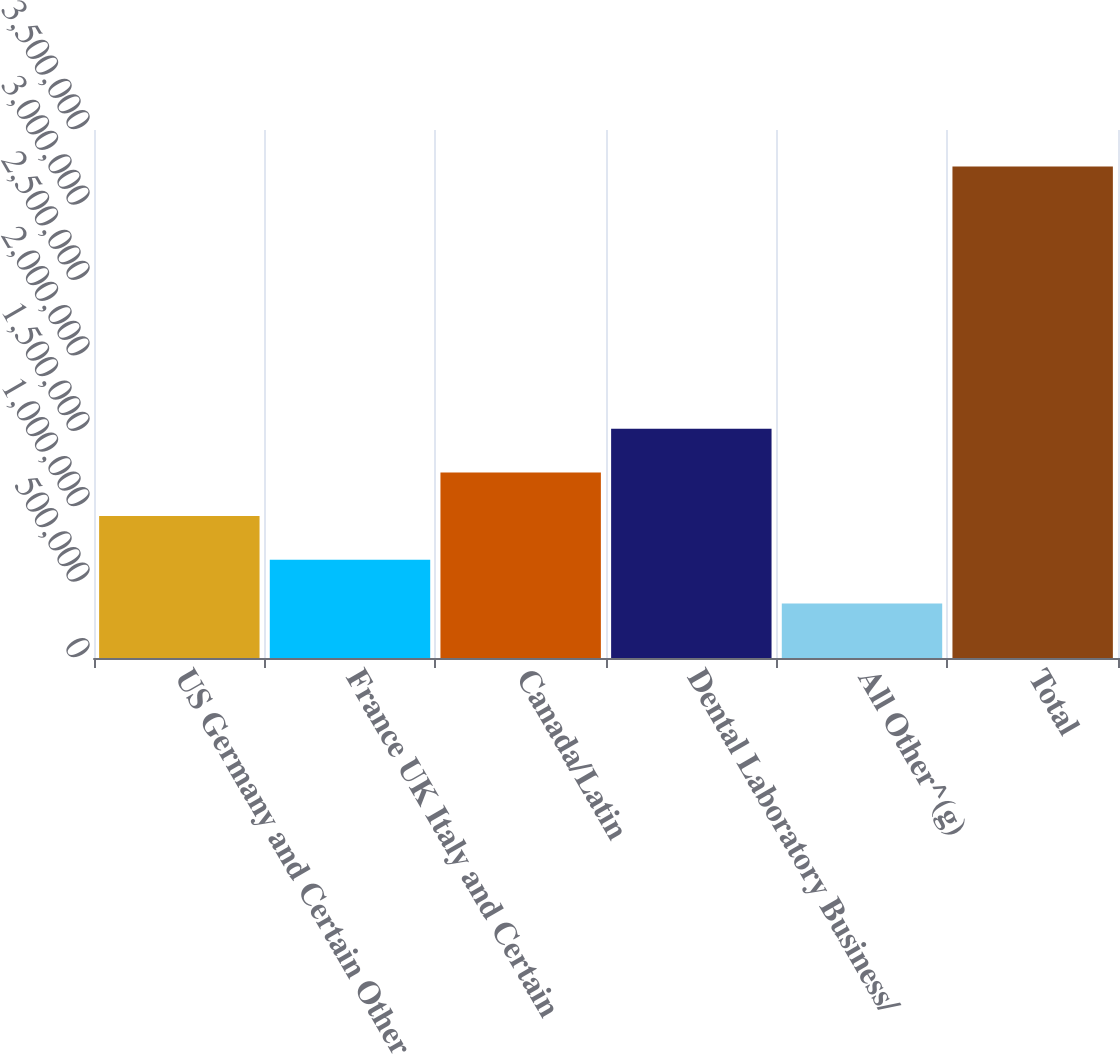Convert chart to OTSL. <chart><loc_0><loc_0><loc_500><loc_500><bar_chart><fcel>US Germany and Certain Other<fcel>France UK Italy and Certain<fcel>Canada/Latin<fcel>Dental Laboratory Business/<fcel>All Other^(g)<fcel>Total<nl><fcel>940705<fcel>651049<fcel>1.23036e+06<fcel>1.52002e+06<fcel>361393<fcel>3.25795e+06<nl></chart> 